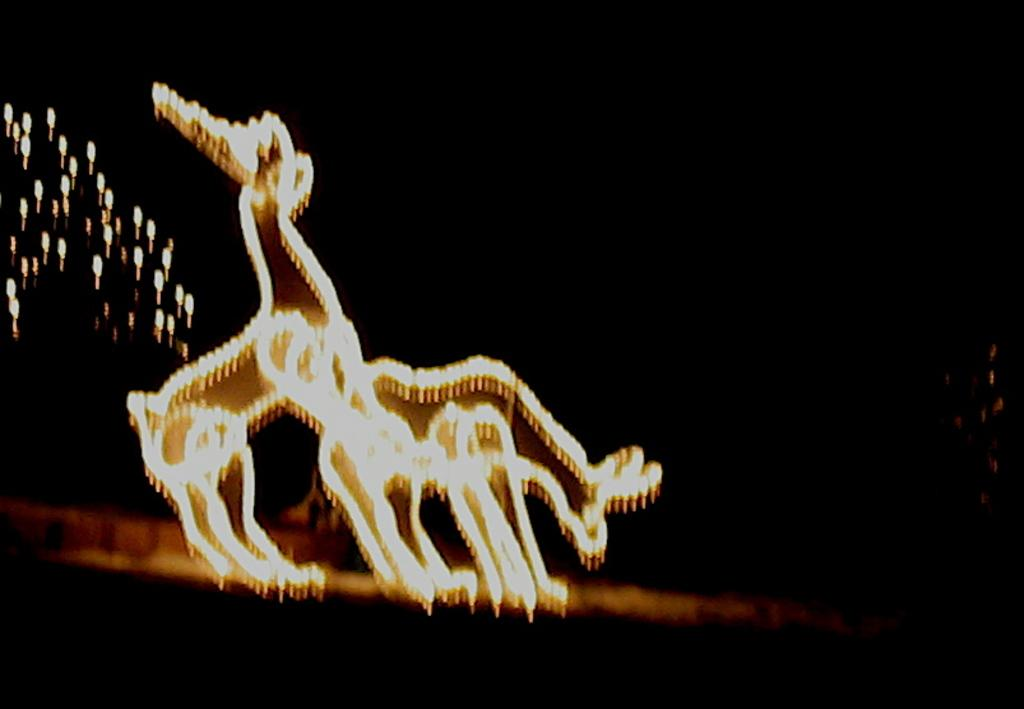What type of decorative elements are present in the image? There are decorative lights in the image. How are the lights arranged? The lights are arranged in the form of animals. What can be observed about the background of the image? The background of the image is dark. What type of hill can be seen in the background of the image? There is no hill present in the background of the image; it is dark. Can you describe the facial expression of the animal formed by the lights? There is no face visible in the image, as the lights are arranged in the form of animals without any facial features. 